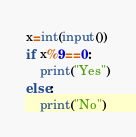<code> <loc_0><loc_0><loc_500><loc_500><_Python_>x=int(input())
if x%9==0:
	print("Yes")
else:
	print("No")</code> 